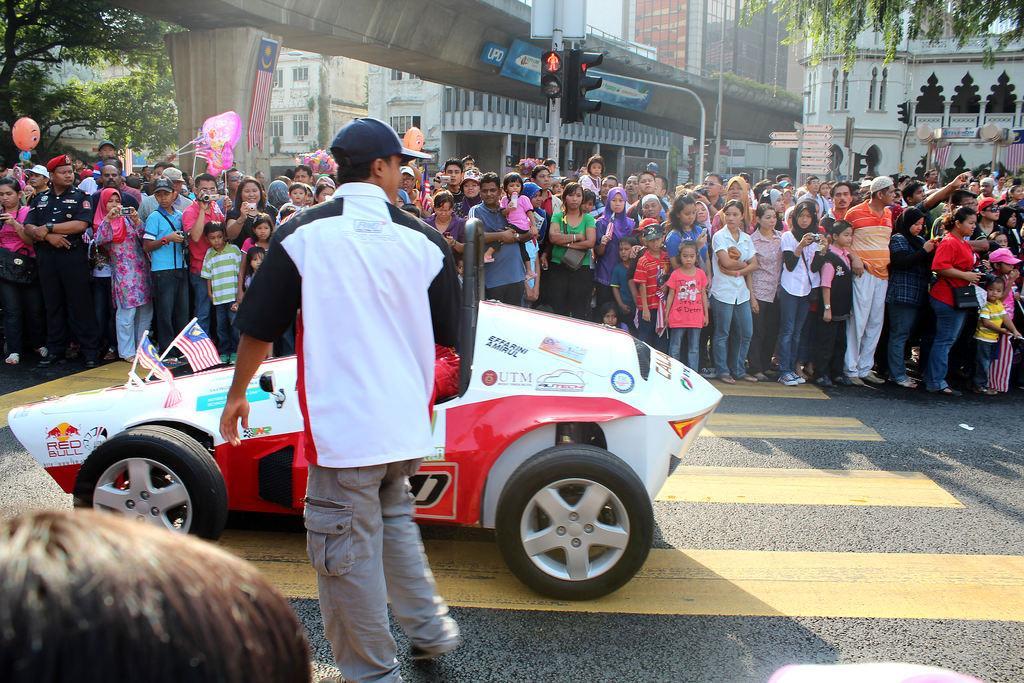Please provide a concise description of this image. In this image we can see a few people, among them some people are holding the objects, we can see a vehicle on the road, there are two flags on the vehicle, also we can see a flyover, there are some buildings, trees, poles, lights and boards with some text. 